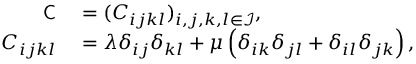<formula> <loc_0><loc_0><loc_500><loc_500>\begin{array} { r l } { C } & = ( C _ { i j k l } ) _ { i , j , k , l \in \mathcal { I } } , } \\ { C _ { i j k l } } & = \lambda \delta _ { i j } \delta _ { k l } + \mu \left ( \delta _ { i k } \delta _ { j l } + \delta _ { i l } \delta _ { j k } \right ) , } \end{array}</formula> 